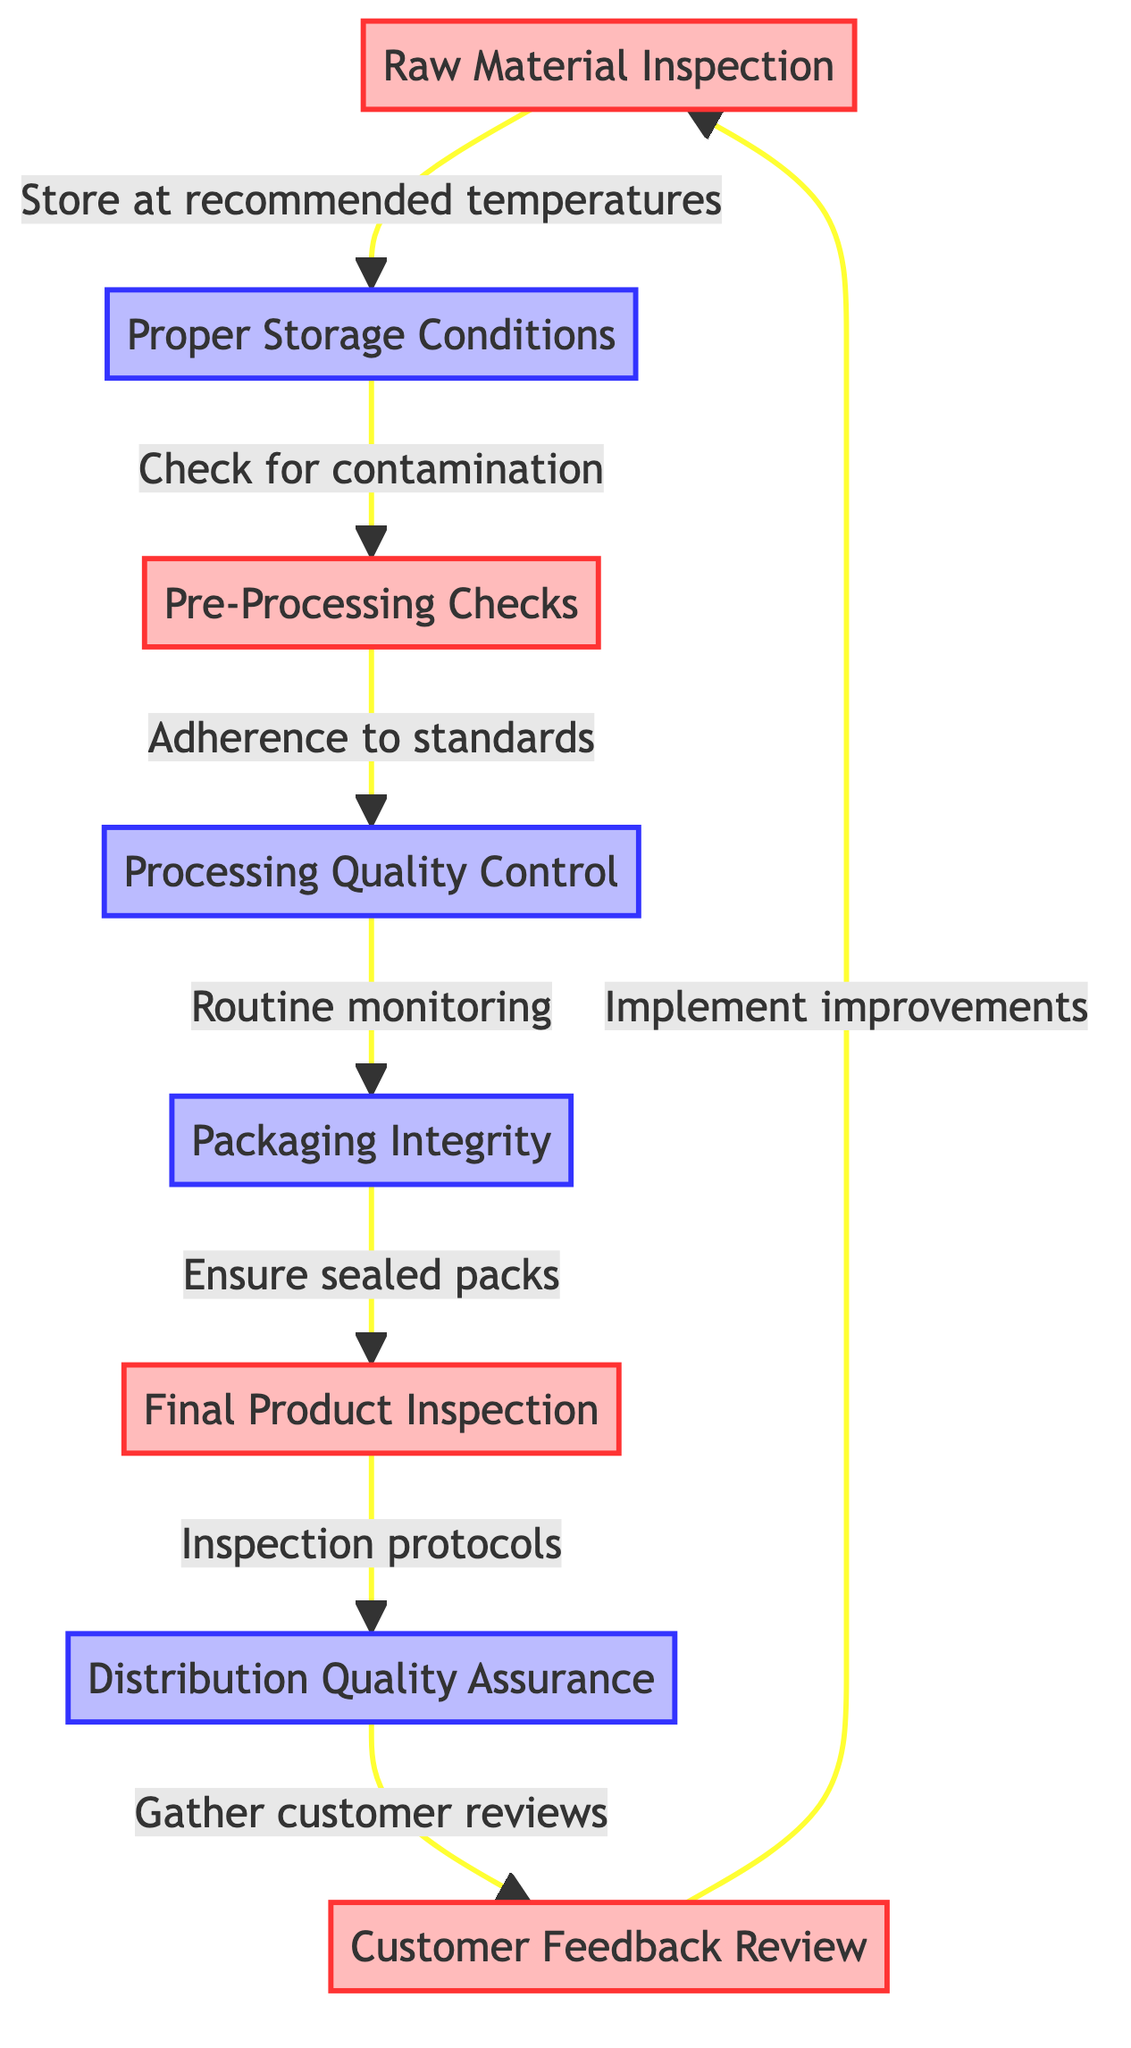What is the first node in the diagram? The first node in the diagram is "Raw Material Inspection." This can be identified as it is the starting point of the flowchart, which leads into "Proper Storage Conditions."
Answer: Raw Material Inspection How many inspection nodes are in the diagram? Counting the nodes labeled as inspection, we have: "Raw Material Inspection," "Pre-Processing Checks," "Final Product Inspection," and "Customer Feedback Review." This totals four inspection nodes.
Answer: Four What step follows "Pre-Processing Checks"? The step that follows "Pre-Processing Checks" is "Processing Quality Control." This can be found in the flow of the diagram where arrows indicate the direction from "Pre-Processing Checks" to "Processing Quality Control."
Answer: Processing Quality Control Which process checks for contamination? The process that checks for contamination is "Proper Storage Conditions." The diagram explicitly states this as the action taken after "Raw Material Inspection."
Answer: Proper Storage Conditions How does customer feedback influence the process? Customer feedback influences the process by leading to "Implement improvements," which is an actionable step directed back to "Raw Material Inspection." This shows the iterative nature of quality control.
Answer: Implement improvements What is the last inspection in the sequence? The last inspection in the sequence is "Customer Feedback Review." This is identified as the final step that gathers reviews before looping back to improve raw materials.
Answer: Customer Feedback Review Which process ensures sealed packs? The process that ensures sealed packs is "Packaging Integrity." This is indicated as an action that follows "Processing Quality Control" in the diagram.
Answer: Packaging Integrity What action is taken after "Final Product Inspection"? The action taken after "Final Product Inspection" is "Distribution Quality Assurance." This is shown by the arrow that flows directly from "Final Product Inspection" to "Distribution Quality Assurance."
Answer: Distribution Quality Assurance What is the purpose of routine monitoring? The purpose of routine monitoring is to maintain quality during "Processing," as indicated by the directional flow from "Processing Quality Control" towards "Packaging Integrity."
Answer: Maintain quality 